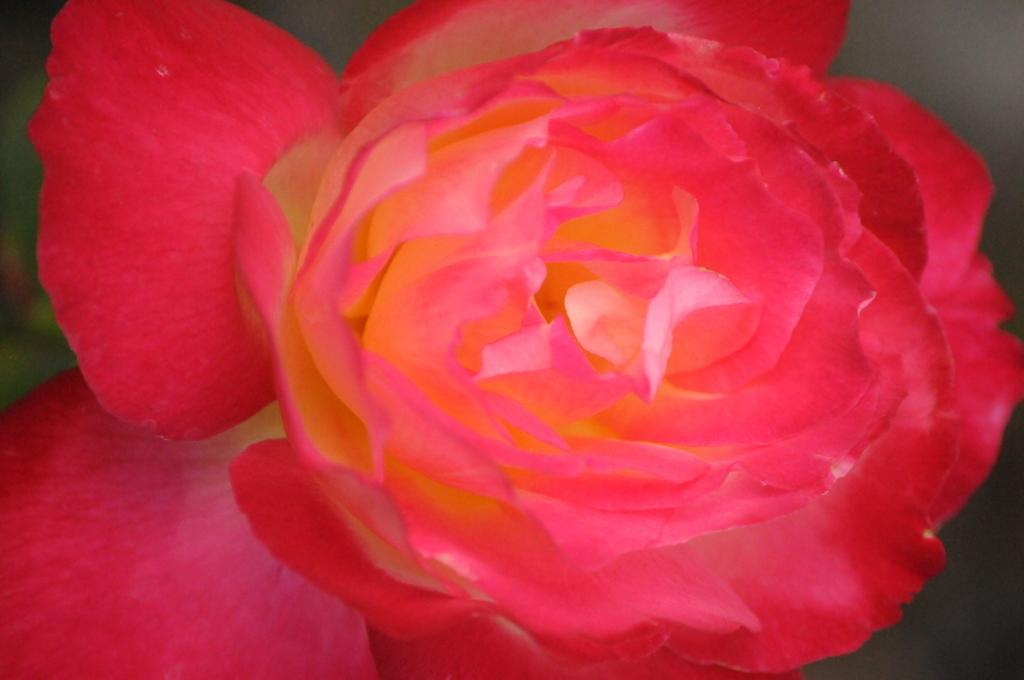What is the main subject of the image? There is a flower in the image. What can be observed about the background of the image? The background of the image is dark. What role does the father play in the image? There is no father present in the image; it features a flower and a dark background. What is the mass of the flower in the image? The mass of the flower cannot be determined from the image alone, as it does not provide any information about the size or weight of the flower. 